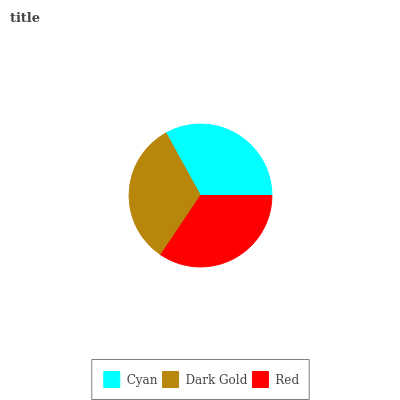Is Dark Gold the minimum?
Answer yes or no. Yes. Is Red the maximum?
Answer yes or no. Yes. Is Red the minimum?
Answer yes or no. No. Is Dark Gold the maximum?
Answer yes or no. No. Is Red greater than Dark Gold?
Answer yes or no. Yes. Is Dark Gold less than Red?
Answer yes or no. Yes. Is Dark Gold greater than Red?
Answer yes or no. No. Is Red less than Dark Gold?
Answer yes or no. No. Is Cyan the high median?
Answer yes or no. Yes. Is Cyan the low median?
Answer yes or no. Yes. Is Red the high median?
Answer yes or no. No. Is Red the low median?
Answer yes or no. No. 